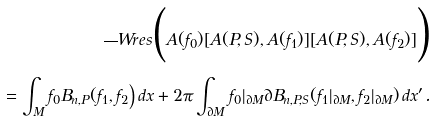<formula> <loc_0><loc_0><loc_500><loc_500>\overline { \ } W r e s \Big ( A ( f _ { 0 } ) [ A ( P , S ) , A ( f _ { 1 } ) ] [ A ( P , S ) , A ( f _ { 2 } ) ] \Big ) \\ = \int _ { M } f _ { 0 } B _ { n , P } ( f _ { 1 } , f _ { 2 } \Big ) \, d x + 2 \pi \int _ { \partial M } f _ { 0 } | _ { \partial M } \partial B _ { n , P , S } ( f _ { 1 } | _ { \partial M } , f _ { 2 } | _ { \partial M } ) \, d x ^ { \prime } .</formula> 